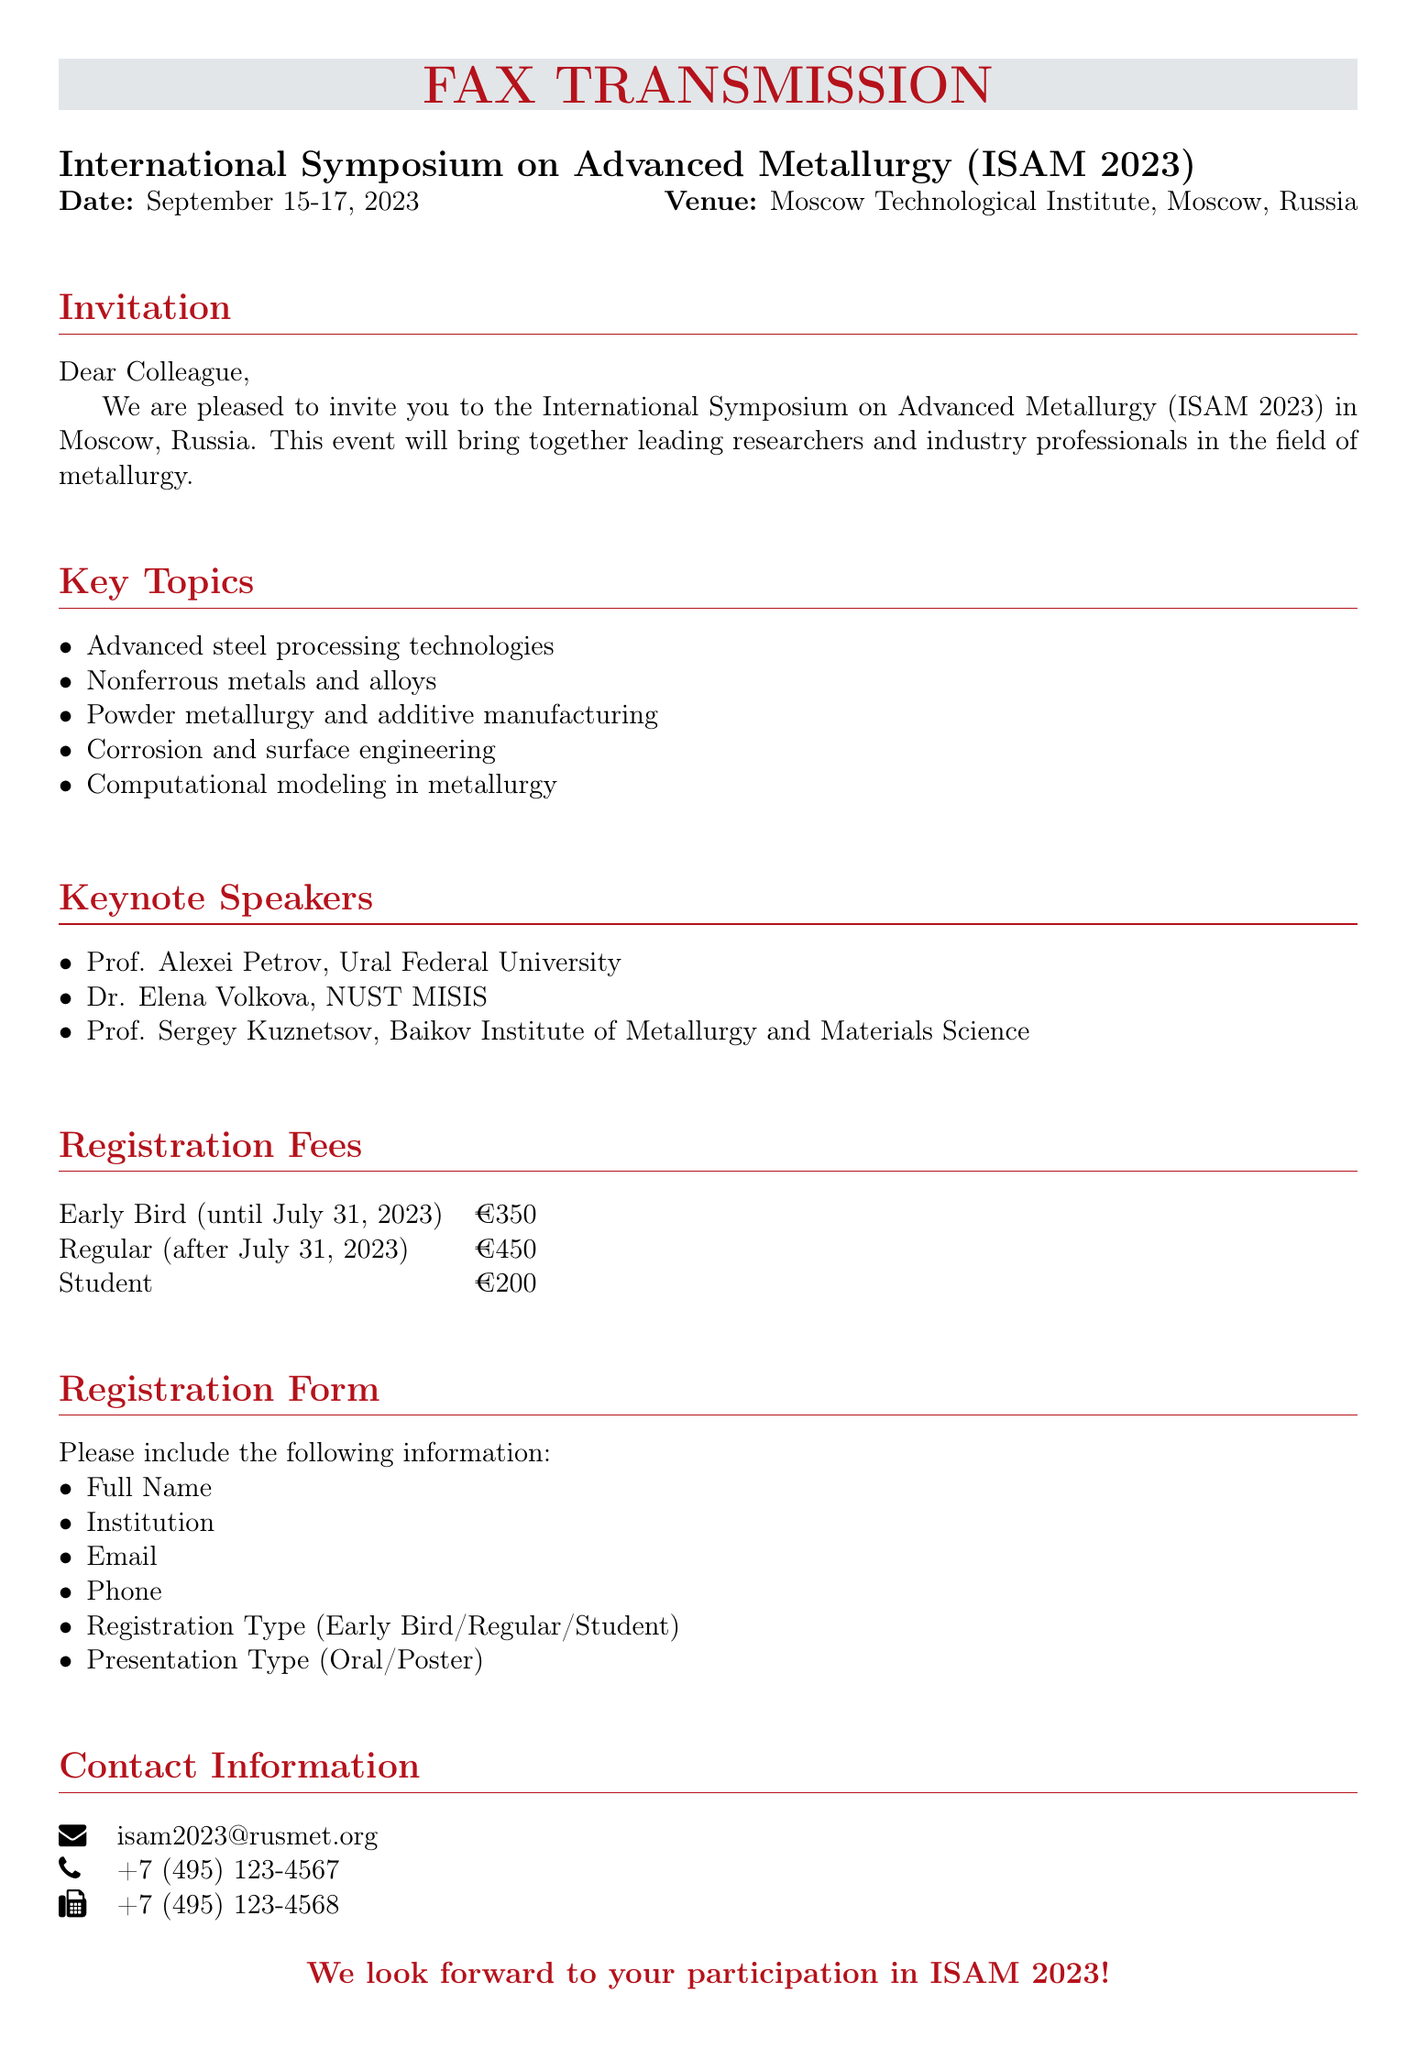What are the dates of the symposium? The document specifies that the International Symposium on Advanced Metallurgy is scheduled from September 15 to September 17, 2023.
Answer: September 15-17, 2023 What is the venue of the event? The venue for the symposium is stated in the document as the Moscow Technological Institute in Moscow, Russia.
Answer: Moscow Technological Institute, Moscow, Russia Who is one of the keynote speakers? The document lists keynote speakers for the event, among them is Prof. Alexei Petrov from Ural Federal University.
Answer: Prof. Alexei Petrov What is the early bird registration fee? The document outlines registration fees, indicating that early bird registration until July 31, 2023 costs €350.
Answer: €350 What information is required in the registration form? The document lists specific information that must be included in the registration form, such as Full Name, Institution, and Email.
Answer: Full Name, Institution, Email, Phone, Registration Type, Presentation Type How many keynote speakers are mentioned? The document lists three keynote speakers, providing the names and their affiliated institutions.
Answer: 3 What is the contact email for the symposium? The document provides a specific email for inquiries related to the event, which is isam2023@rusmet.org.
Answer: isam2023@rusmet.org What is the price for student registration? The document states that the registration fee for students is €200.
Answer: €200 What are the key topics of the symposium? The document outlines several key topics that will be discussed during the symposium, covering areas like advanced steel processing technologies and powder metallurgy.
Answer: Advanced steel processing technologies, Nonferrous metals and alloys, Powder metallurgy and additive manufacturing, Corrosion and surface engineering, Computational modeling in metallurgy 